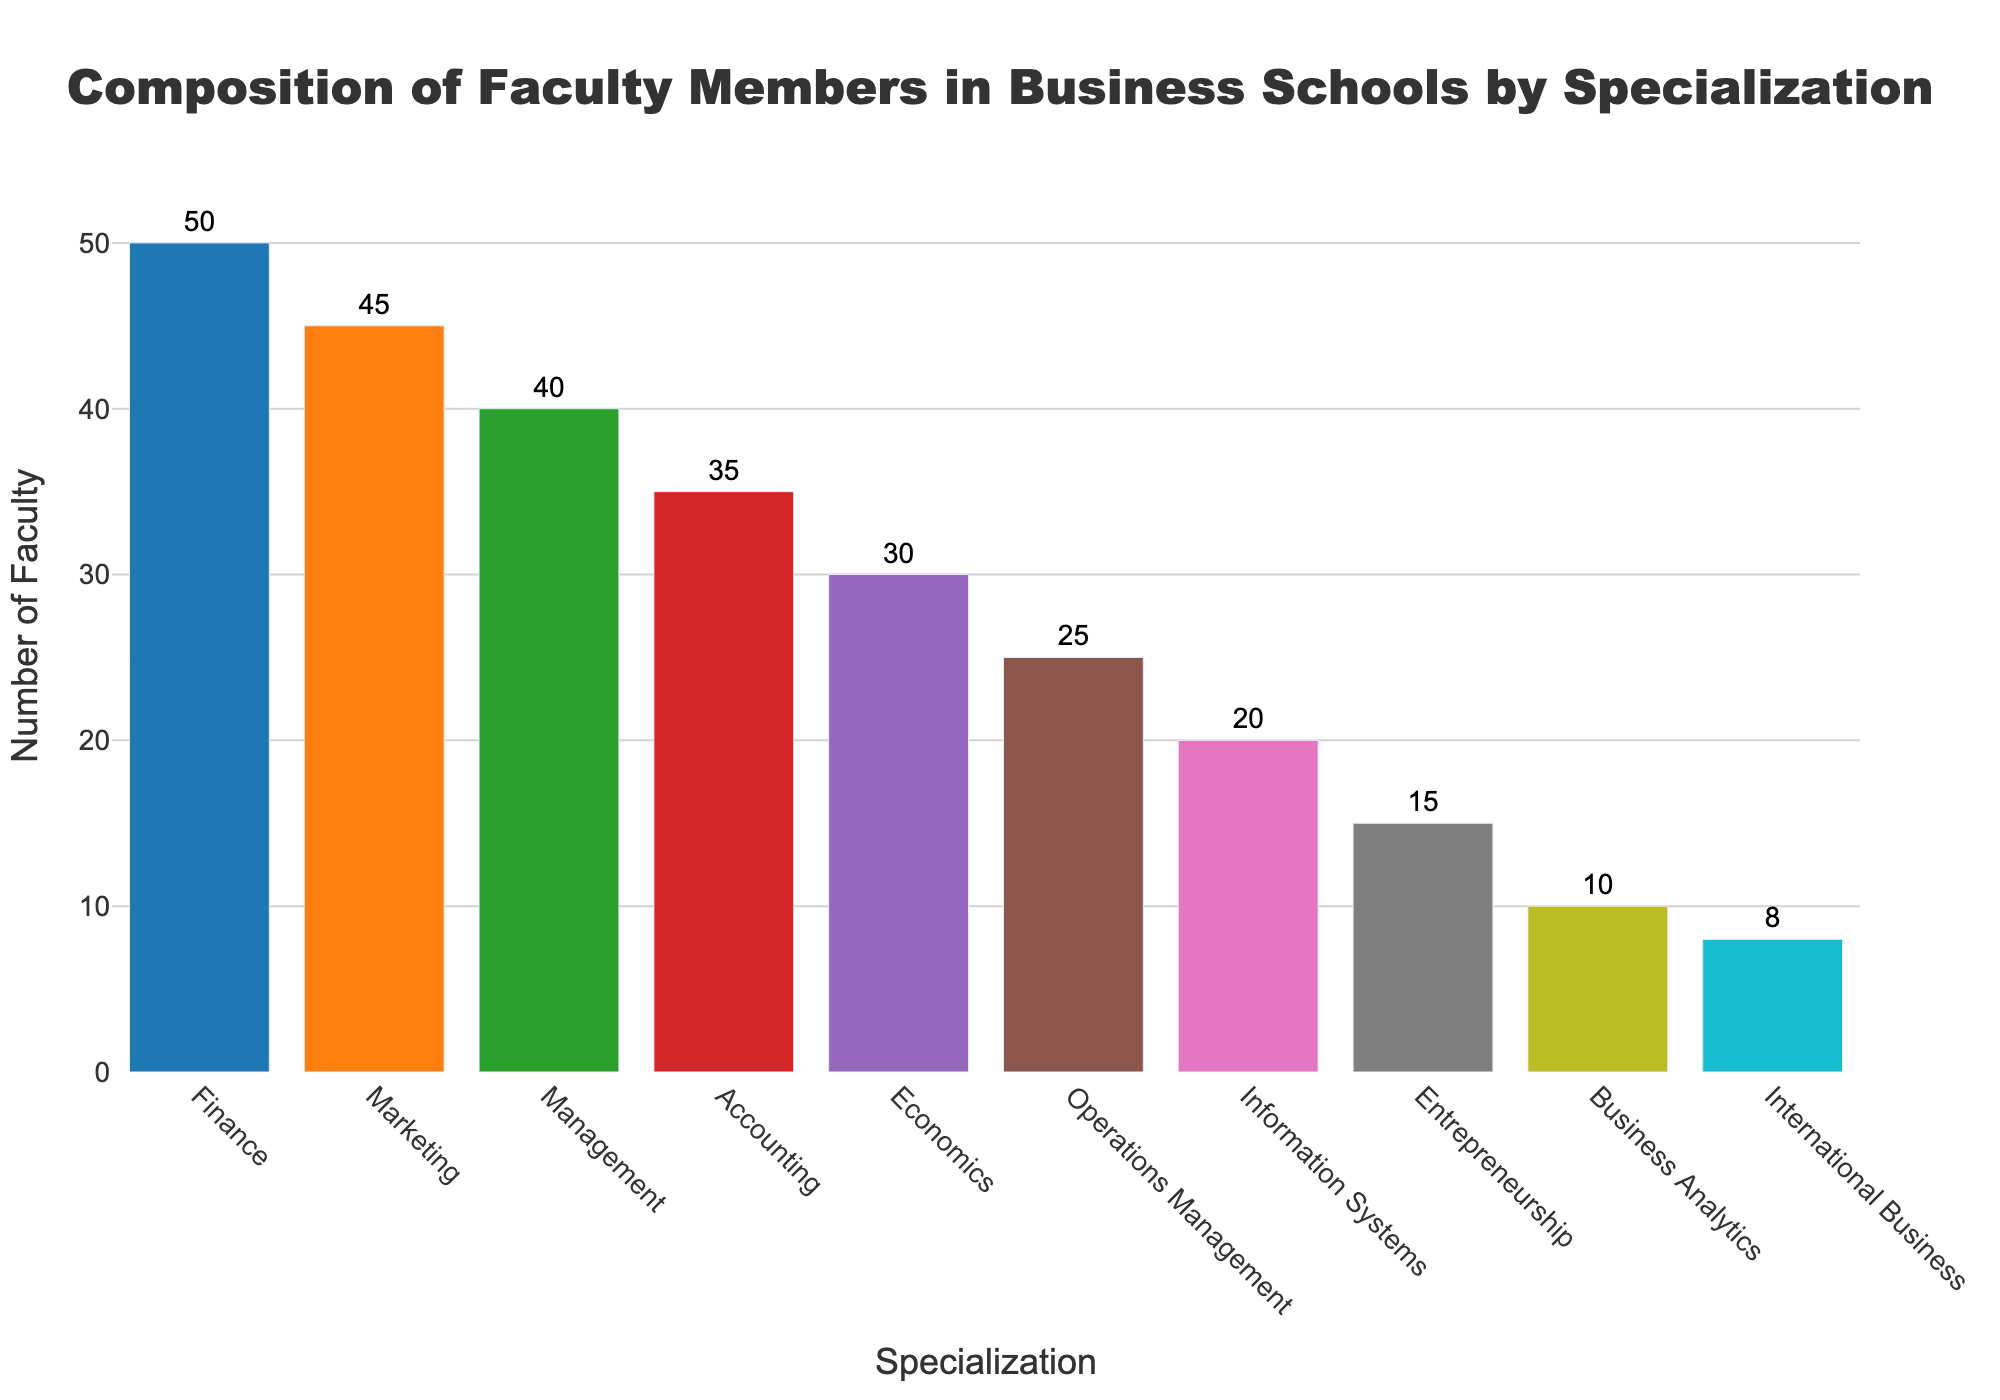What's the title of the plot? The title of the plot is located at the top center of the figure. It reads "Composition of Faculty Members in Business Schools by Specialization".
Answer: Composition of Faculty Members in Business Schools by Specialization How many specializations are listed in the plot? You can count the different bar segments in the plot, each representing a specialization.
Answer: 10 Which specialization has the highest number of faculty members? Look for the tallest bar in the plot.
Answer: Finance What's the total number of faculty members across all specializations? Sum the values of all bars: 50 + 45 + 40 + 35 + 30 + 25 + 20 + 15 + 10 + 8 = 278.
Answer: 278 Which specialization has the lowest number of faculty members? Look for the shortest bar in the plot.
Answer: International Business How many faculty members are there in Marketing compared to Management? Identify the bars for Marketing and Management and compare their heights. Marketing has 45, and Management has 40. The difference is 45 - 40 = 5.
Answer: Marketing has 5 more faculty members than Management Calculate the average number of faculty members per specialization. Divide the total number of faculty (278) by the number of specializations (10). 278 / 10 = 27.8.
Answer: 27.8 Do Marketing and Accounting combined have more faculty members than Finance and Economics combined? Sum the values: Marketing + Accounting = 45 + 35 = 80; Finance + Economics = 50 + 30 = 80.
Answer: No, both combinations have the same number of faculty members How many more faculty members does Operations Management have compared to Business Analytics? Identify the values and calculate the difference: Operations Management has 25, Business Analytics has 10. The difference is 25 - 10 = 15.
Answer: 15 Which specializations have fewer faculty members than the average number of faculty members per specialization? The average is 27.8, so look for bars shorter than this height: Information Systems (20), Entrepreneurship (15), Business Analytics (10), and International Business (8).
Answer: Information Systems, Entrepreneurship, Business Analytics, International Business 